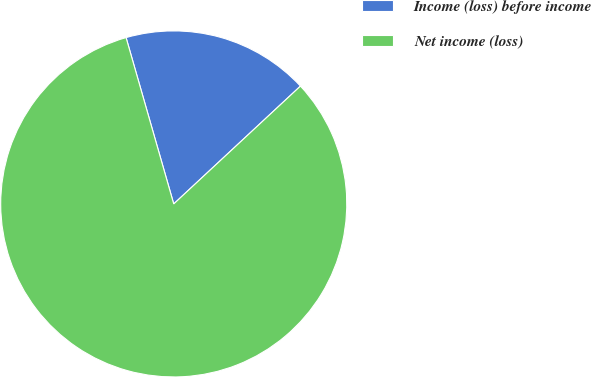<chart> <loc_0><loc_0><loc_500><loc_500><pie_chart><fcel>Income (loss) before income<fcel>Net income (loss)<nl><fcel>17.52%<fcel>82.48%<nl></chart> 